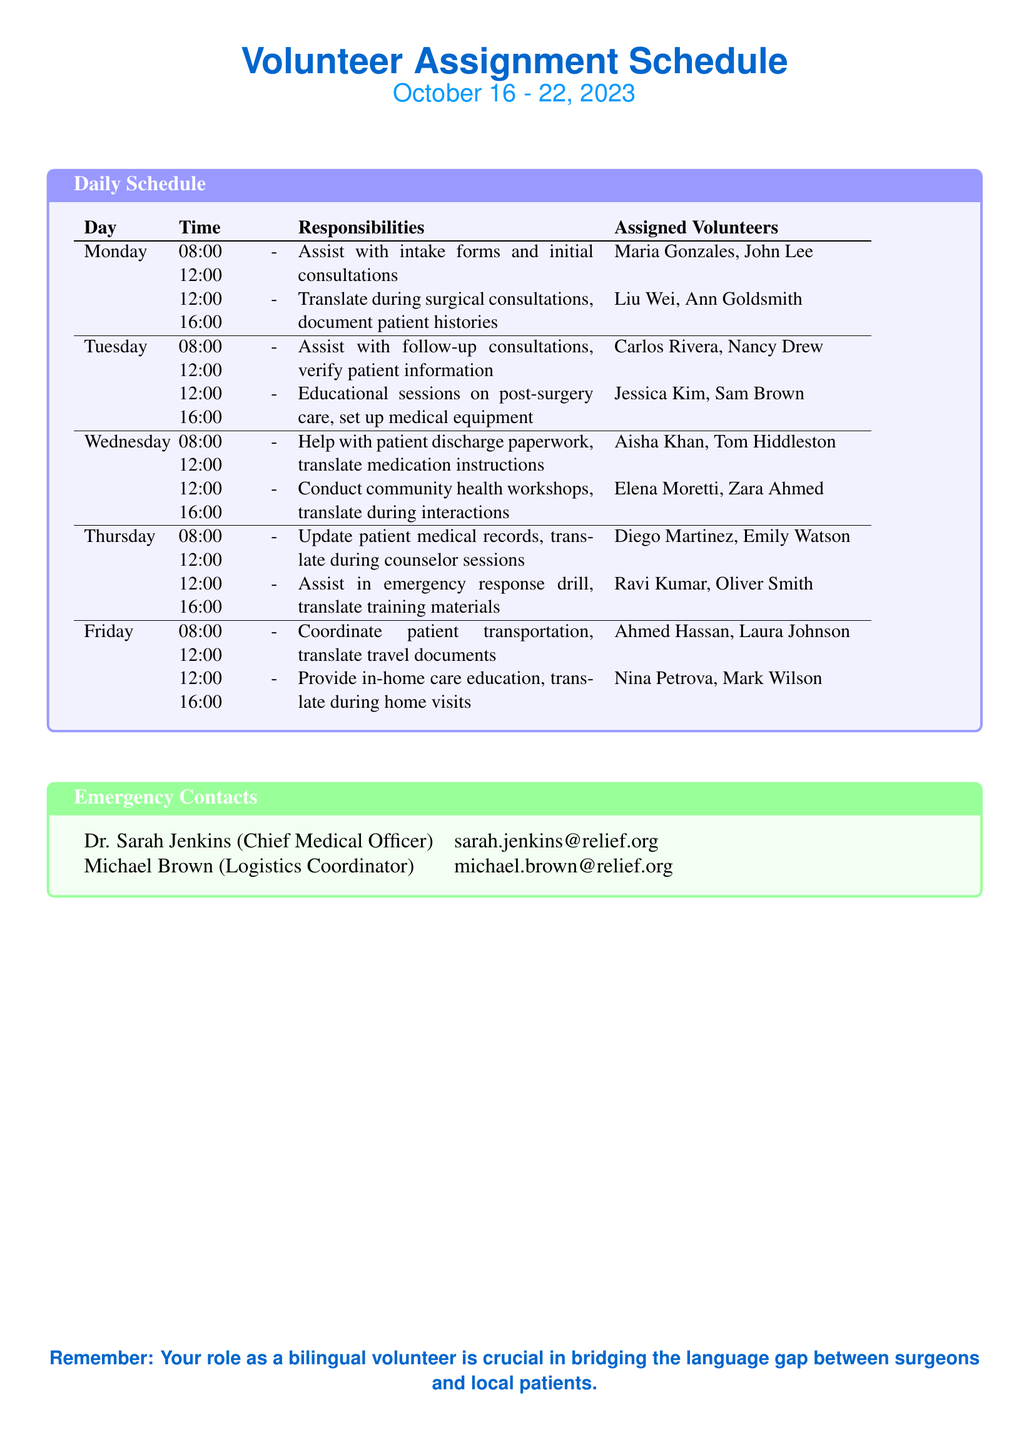what are the assigned volunteers for Monday morning? The document lists the volunteers assigned for Monday morning under the responsibilities section for that time slot, which includes Maria Gonzales and John Lee.
Answer: Maria Gonzales, John Lee what is the responsibility for Wednesday afternoon? The responsibility for Wednesday afternoon is found in the schedule, which states that volunteers will conduct community health workshops and translate during interactions.
Answer: Conduct community health workshops, translate during interactions who is the Chief Medical Officer? The document specifies the emergency contact for the Chief Medical Officer, which is Dr. Sarah Jenkins.
Answer: Dr. Sarah Jenkins what time does the Tuesday morning shift start? The schedule indicates the start time for the Tuesday morning shift, which is at 8:00 AM.
Answer: 08:00 which volunteers are assisting with follow-up consultations on Tuesday? The volunteers assigned for follow-up consultations on Tuesday are listed in the responsibilities section, which includes Carlos Rivera and Nancy Drew.
Answer: Carlos Rivera, Nancy Drew how many shifts are there on Thursday? By examining the daily schedule, Thursday has two shifts listed, one in the morning and one in the afternoon.
Answer: 2 what type of sessions will be held on Tuesday afternoon? The Tuesday afternoon responsibilities section details that educational sessions on post-surgery care will be conducted, which is the focus of that time block.
Answer: Educational sessions on post-surgery care who should be contacted for logistics issues? The document provides the name of the logistics coordinator, which identifies Michael Brown as the contact person for logistics issues.
Answer: Michael Brown 